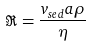<formula> <loc_0><loc_0><loc_500><loc_500>\Re = \frac { v _ { s e d } a \rho } { \eta }</formula> 